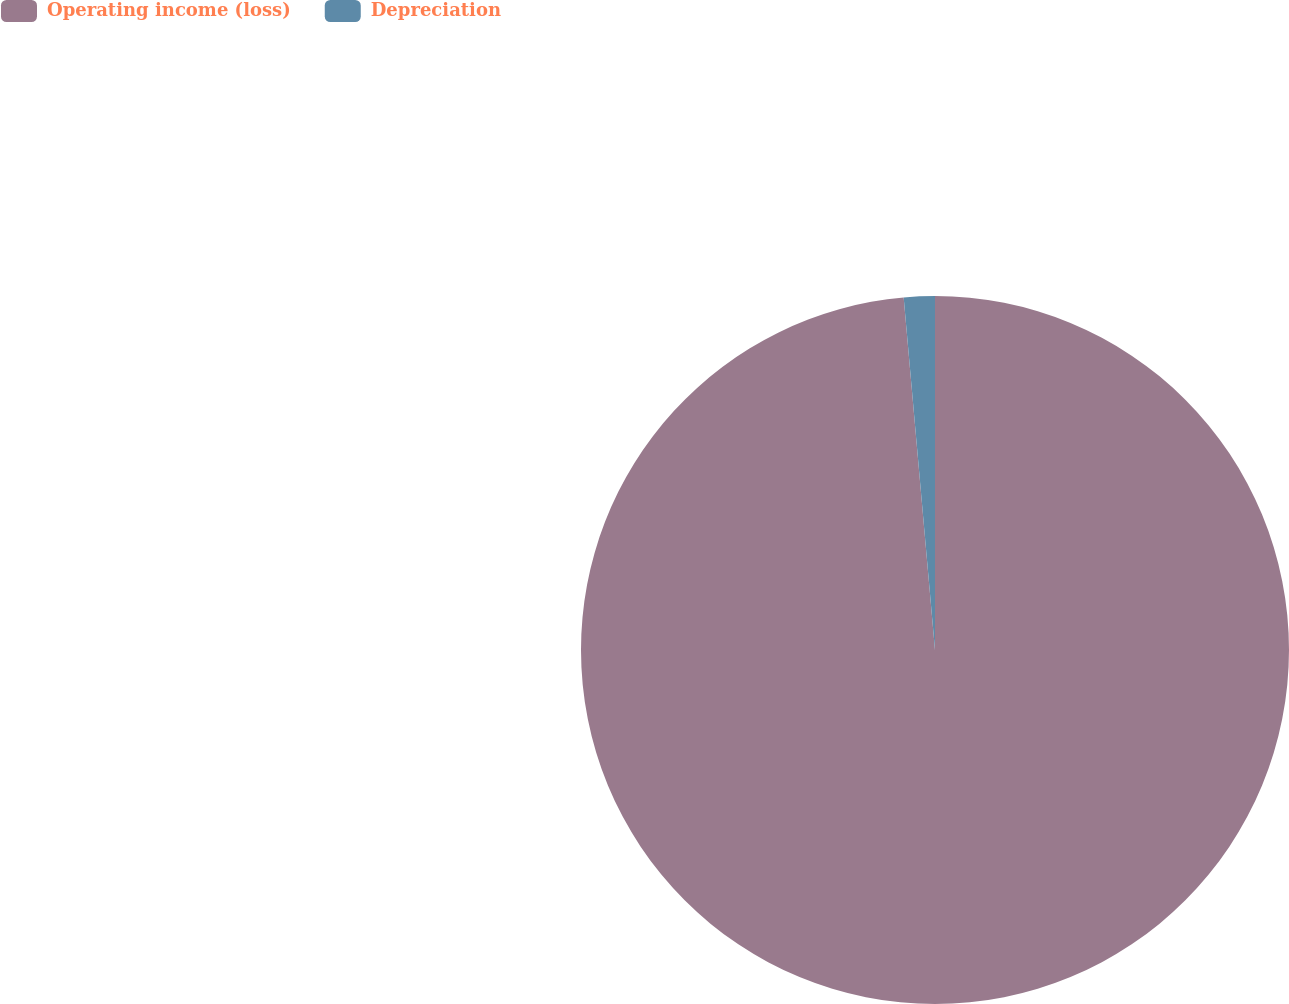<chart> <loc_0><loc_0><loc_500><loc_500><pie_chart><fcel>Operating income (loss)<fcel>Depreciation<nl><fcel>98.59%<fcel>1.41%<nl></chart> 